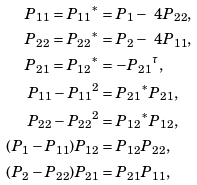<formula> <loc_0><loc_0><loc_500><loc_500>P _ { 1 1 } = { P _ { 1 1 } } ^ { * } & = P _ { 1 } - \ 4 { P _ { 2 2 } } , \\ P _ { 2 2 } = { P _ { 2 2 } } ^ { * } & = P _ { 2 } - \ 4 { P _ { 1 1 } } , \\ P _ { 2 1 } = { P _ { 1 2 } } ^ { * } & = - { P _ { 2 1 } } ^ { \tau } , \\ P _ { 1 1 } - { P _ { 1 1 } } ^ { 2 } & = { P _ { 2 1 } } ^ { * } P _ { 2 1 } , \\ P _ { 2 2 } - { P _ { 2 2 } } ^ { 2 } & = { P _ { 1 2 } } ^ { * } P _ { 1 2 } , \\ ( P _ { 1 } - P _ { 1 1 } ) P _ { 1 2 } & = P _ { 1 2 } P _ { 2 2 } , \\ ( P _ { 2 } - P _ { 2 2 } ) P _ { 2 1 } & = P _ { 2 1 } P _ { 1 1 } ,</formula> 